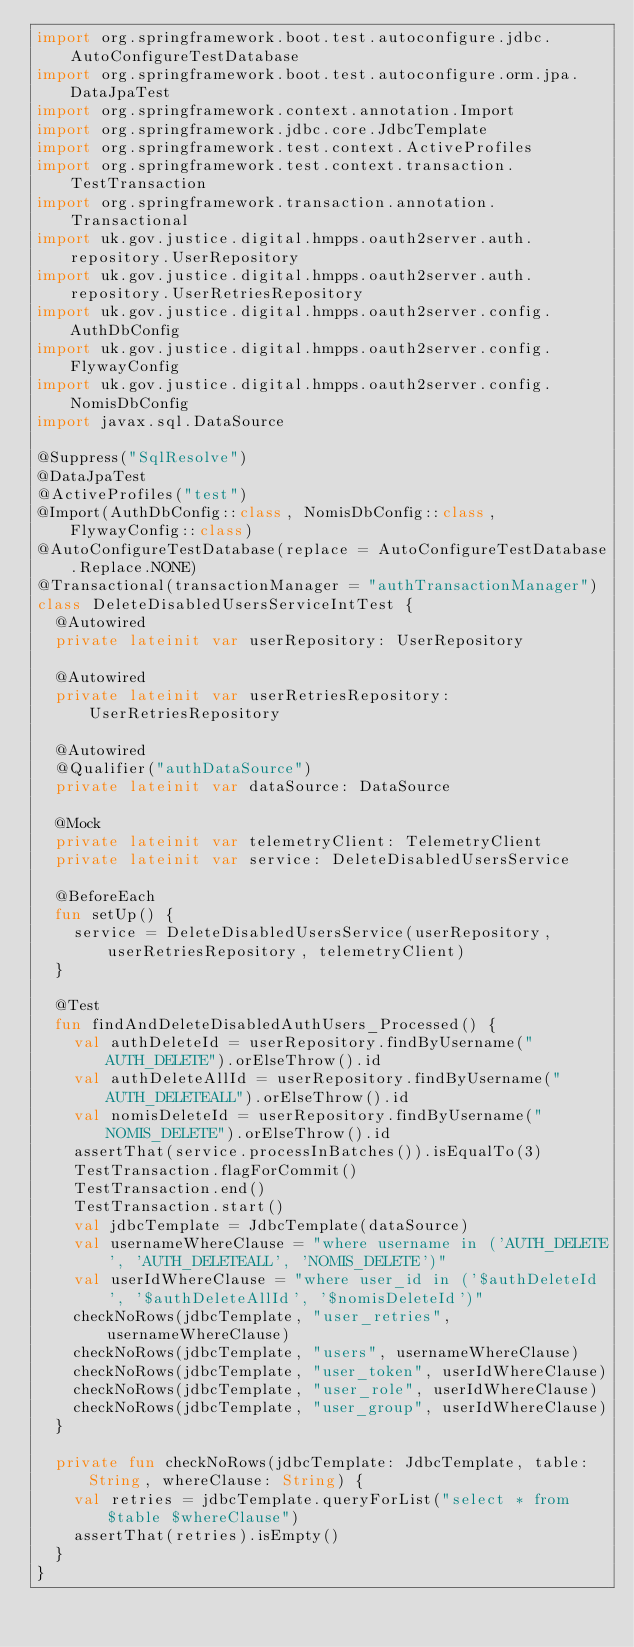Convert code to text. <code><loc_0><loc_0><loc_500><loc_500><_Kotlin_>import org.springframework.boot.test.autoconfigure.jdbc.AutoConfigureTestDatabase
import org.springframework.boot.test.autoconfigure.orm.jpa.DataJpaTest
import org.springframework.context.annotation.Import
import org.springframework.jdbc.core.JdbcTemplate
import org.springframework.test.context.ActiveProfiles
import org.springframework.test.context.transaction.TestTransaction
import org.springframework.transaction.annotation.Transactional
import uk.gov.justice.digital.hmpps.oauth2server.auth.repository.UserRepository
import uk.gov.justice.digital.hmpps.oauth2server.auth.repository.UserRetriesRepository
import uk.gov.justice.digital.hmpps.oauth2server.config.AuthDbConfig
import uk.gov.justice.digital.hmpps.oauth2server.config.FlywayConfig
import uk.gov.justice.digital.hmpps.oauth2server.config.NomisDbConfig
import javax.sql.DataSource

@Suppress("SqlResolve")
@DataJpaTest
@ActiveProfiles("test")
@Import(AuthDbConfig::class, NomisDbConfig::class, FlywayConfig::class)
@AutoConfigureTestDatabase(replace = AutoConfigureTestDatabase.Replace.NONE)
@Transactional(transactionManager = "authTransactionManager")
class DeleteDisabledUsersServiceIntTest {
  @Autowired
  private lateinit var userRepository: UserRepository

  @Autowired
  private lateinit var userRetriesRepository: UserRetriesRepository

  @Autowired
  @Qualifier("authDataSource")
  private lateinit var dataSource: DataSource

  @Mock
  private lateinit var telemetryClient: TelemetryClient
  private lateinit var service: DeleteDisabledUsersService

  @BeforeEach
  fun setUp() {
    service = DeleteDisabledUsersService(userRepository, userRetriesRepository, telemetryClient)
  }

  @Test
  fun findAndDeleteDisabledAuthUsers_Processed() {
    val authDeleteId = userRepository.findByUsername("AUTH_DELETE").orElseThrow().id
    val authDeleteAllId = userRepository.findByUsername("AUTH_DELETEALL").orElseThrow().id
    val nomisDeleteId = userRepository.findByUsername("NOMIS_DELETE").orElseThrow().id
    assertThat(service.processInBatches()).isEqualTo(3)
    TestTransaction.flagForCommit()
    TestTransaction.end()
    TestTransaction.start()
    val jdbcTemplate = JdbcTemplate(dataSource)
    val usernameWhereClause = "where username in ('AUTH_DELETE', 'AUTH_DELETEALL', 'NOMIS_DELETE')"
    val userIdWhereClause = "where user_id in ('$authDeleteId', '$authDeleteAllId', '$nomisDeleteId')"
    checkNoRows(jdbcTemplate, "user_retries", usernameWhereClause)
    checkNoRows(jdbcTemplate, "users", usernameWhereClause)
    checkNoRows(jdbcTemplate, "user_token", userIdWhereClause)
    checkNoRows(jdbcTemplate, "user_role", userIdWhereClause)
    checkNoRows(jdbcTemplate, "user_group", userIdWhereClause)
  }

  private fun checkNoRows(jdbcTemplate: JdbcTemplate, table: String, whereClause: String) {
    val retries = jdbcTemplate.queryForList("select * from $table $whereClause")
    assertThat(retries).isEmpty()
  }
}
</code> 